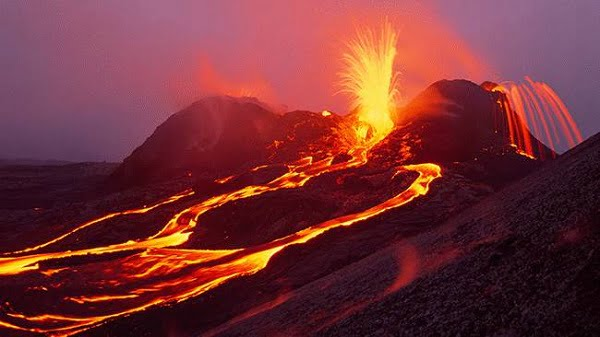Can you elaborate on the elements of the picture provided?
 The image captures a dramatic scene from the Hawaii Volcanoes National Park. A volcanic eruption is in progress, with bright orange lava flowing down the sides of the volcano. The lava streams are moving in multiple directions, creating a dynamic and powerful display of nature's force. The sky above is a dark gray, providing a stark contrast to the vibrant lava. The landscape surrounding the volcano appears barren, emphasizing the isolation and raw beauty of the scene. The image is taken from a distance, allowing a full view of the volcano and the surrounding area. This perspective underscores the magnitude of the eruption and the vastness of the landscape. The image is a vivid representation of the power and majesty of nature as seen in the Hawaii Volcanoes National Park. 